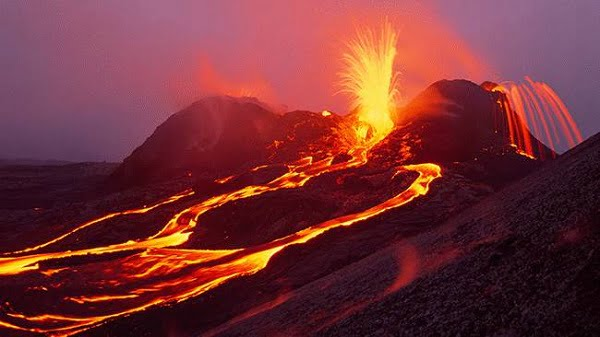Can you elaborate on the elements of the picture provided?
 The image captures a dramatic scene from the Hawaii Volcanoes National Park. A volcanic eruption is in progress, with bright orange lava flowing down the sides of the volcano. The lava streams are moving in multiple directions, creating a dynamic and powerful display of nature's force. The sky above is a dark gray, providing a stark contrast to the vibrant lava. The landscape surrounding the volcano appears barren, emphasizing the isolation and raw beauty of the scene. The image is taken from a distance, allowing a full view of the volcano and the surrounding area. This perspective underscores the magnitude of the eruption and the vastness of the landscape. The image is a vivid representation of the power and majesty of nature as seen in the Hawaii Volcanoes National Park. 